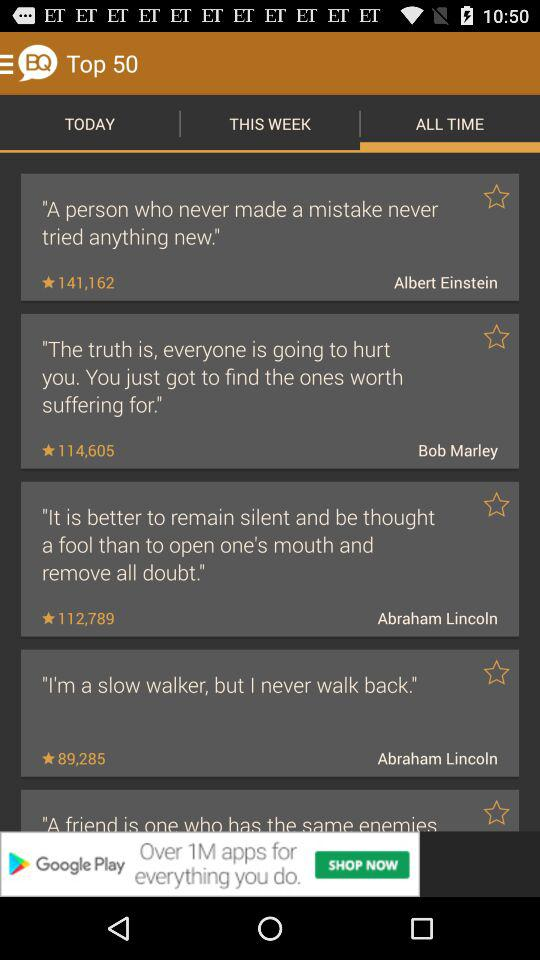How many statements wrote by Abraham Lincoln?
When the provided information is insufficient, respond with <no answer>. <no answer> 